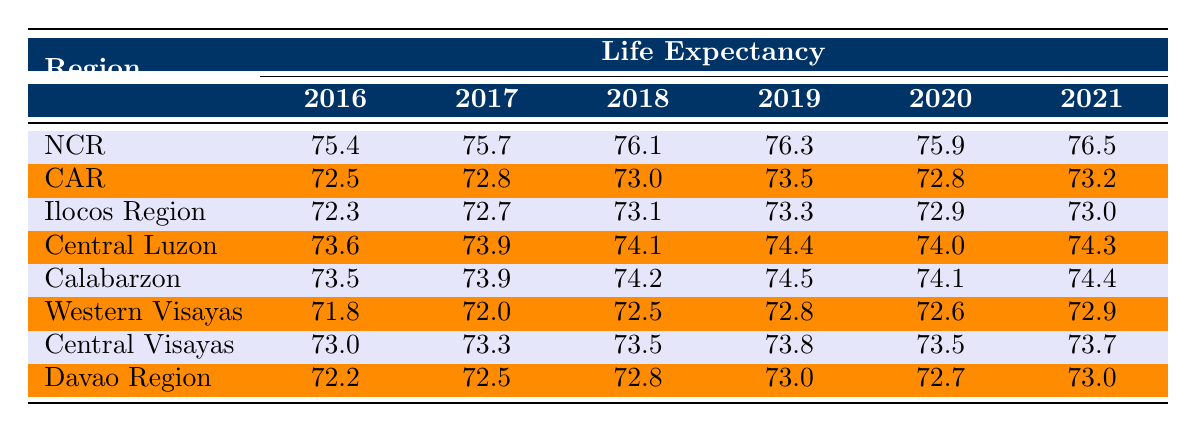What was the life expectancy in the National Capital Region in 2020? From the table, the life expectancy listed for the National Capital Region (NCR) in 2020 is 75.9.
Answer: 75.9 Which region had the highest life expectancy in 2021? The highest life expectancy in 2021 is found in the National Capital Region (NCR) at 76.5, compared to all other regions.
Answer: NCR What is the average life expectancy for the Cordillera Administrative Region from 2016 to 2021? To find the average, we first sum the life expectancy values: (72.5 + 72.8 + 73.0 + 73.5 + 72.8 + 73.2) = 437.8. There are 6 years, so the average is 437.8 / 6 ≈ 72.97.
Answer: 72.97 Did the life expectancy in Davao Region increase from 2016 to 2021? Analyzing the data from the table, the life expectancy in the Davao Region increased from 72.2 in 2016 to 73.0 in 2021, indicating an increase.
Answer: Yes What is the difference in life expectancy between the Ilocos Region and the Calabarzon in 2019? The life expectancy in Ilocos Region in 2019 is 73.3 and in Calabarzon is 74.5. The difference is calculated as 74.5 - 73.3 = 1.2.
Answer: 1.2 How did the life expectancy for Central Visayas change from 2016 to 2020? Central Visayas had a life expectancy of 73.0 in 2016 and 73.5 in 2020. This indicates an increase of 0.5, moving from 73.0 to 73.5.
Answer: Increased by 0.5 Which region had the lowest life expectancy in 2018? The lowest life expectancy in 2018 is from the Western Visayas at 72.5, which is lower than all other regions listed for that year.
Answer: Western Visayas What was the trend in life expectancy for Central Luzon from 2016 to 2021? The trend shows successive increases from 73.6 (2016) to 74.3 (2021), with some years seeing a slight decline, particularly in 2020 (74.0). Overall, the trend is upward.
Answer: Upward trend with slight decline in 2020 